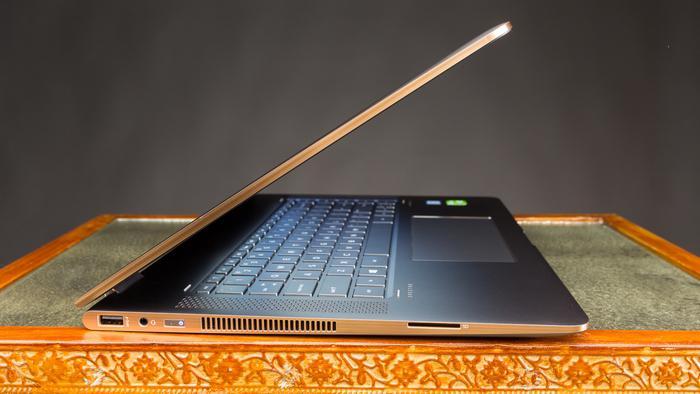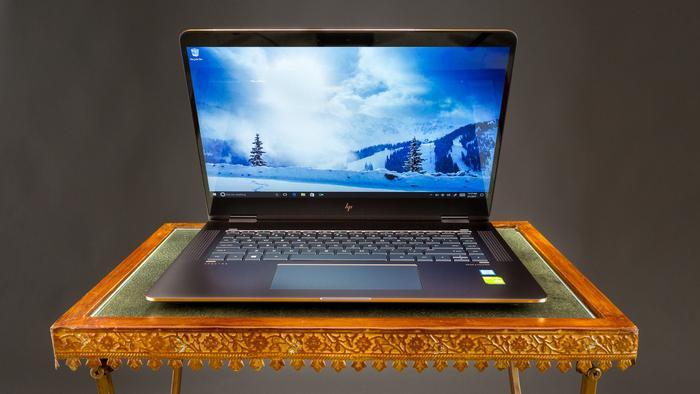The first image is the image on the left, the second image is the image on the right. Evaluate the accuracy of this statement regarding the images: "At least one image shows a straight-on side view of a laptop that is opened at less than a 45-degree angle.". Is it true? Answer yes or no. Yes. 